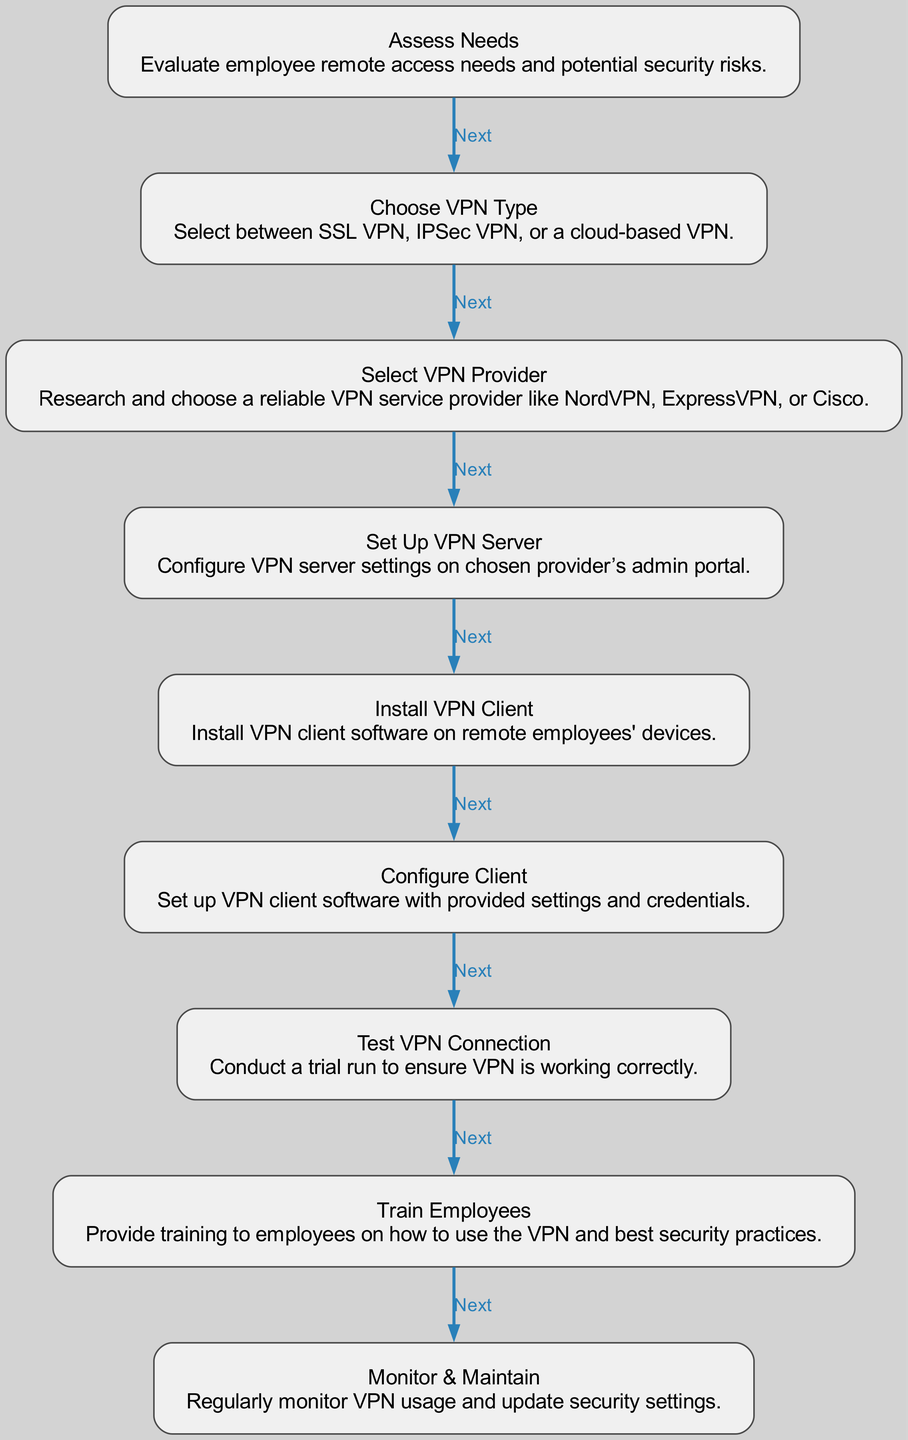What is the first step in the VPN setup workflow? The diagram shows that the first step is labeled "Assess Needs," which involves evaluating employee remote access needs and potential security risks. Therefore, the correct answer is "Assess Needs."
Answer: Assess Needs How many nodes are present in the diagram? By counting each unique step in the VPN setup workflow depicted in the diagram, there are nine nodes in total, each representing a different part of the VPN setup process.
Answer: 9 What type of VPN does the diagram suggest to choose? The second node in the diagram is labeled "Choose VPN Type," which indicates that various options such as SSL VPN, IPSec VPN, or a cloud-based VPN should be selected, but the node doesn't specify just one type. Thus, the answer reflects multiple options.
Answer: SSL VPN, IPSec VPN, or cloud-based VPN Which node comes after "Test VPN Connection"? According to the flow of the diagram, after "Test VPN Connection," the next step is "Train Employees,” indicating that training is necessary after testing the VPN connection.
Answer: Train Employees What is the last step in the VPN setup process? The diagram clearly outlines that the final step is labeled "Monitor & Maintain," which signifies the ongoing requirement to monitor VPN usage and update security settings.
Answer: Monitor & Maintain What is required in the "Select VPN Provider" step? In the "Select VPN Provider" node, the description states that one should research and choose a reliable VPN service provider. This indicates that thorough evaluation is crucial in this step.
Answer: Research and choose a reliable VPN service provider Which nodes are directly connected to "Install VPN Client"? From the diagram, "Install VPN Client" is connected to "Set Up VPN Server" before it, and to "Configure Client" after it. This shows a direct sequence in the workflow without any other nodes in between.
Answer: Set Up VPN Server and Configure Client What key aspect should be included in the "Train Employees" step? The "Train Employees" node emphasizes that the training should cover how to use the VPN and best security practices. This is critical for ensuring employees understand their importance in maintaining VPN integrity.
Answer: Best security practices How does the node "Configure Client" relate to the overall workflow? The "Configure Client" node is essential as it comes sequentially after "Install VPN Client," showing that correct configuration with settings and credentials is required for successful VPN operation, reinforcing the overall workflow's purpose.
Answer: It is a necessary step for successful VPN operation 